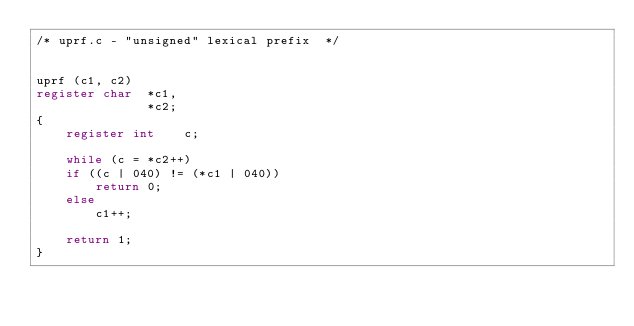Convert code to text. <code><loc_0><loc_0><loc_500><loc_500><_C_>/* uprf.c - "unsigned" lexical prefix  */


uprf (c1, c2)
register char  *c1,
               *c2;
{
    register int    c;

    while (c = *c2++)
	if ((c | 040) != (*c1 | 040))
	    return 0;
	else
	    c1++;

    return 1;
}
</code> 